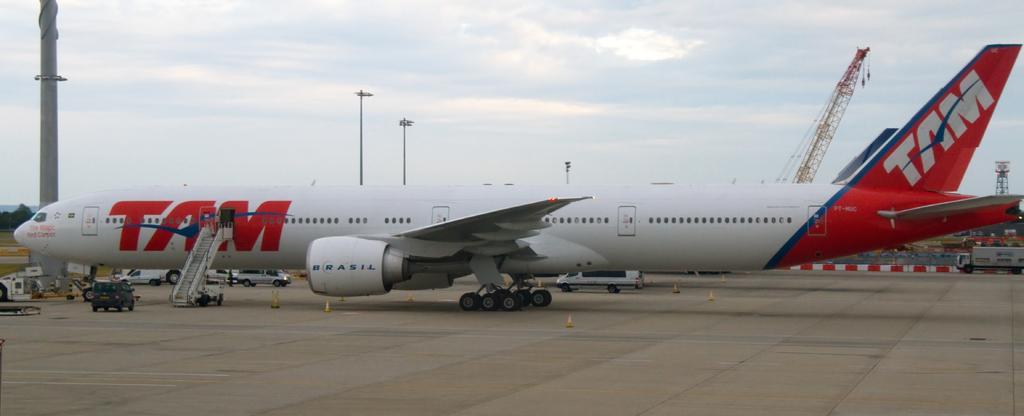Please provide a concise description of this image. In this image we can see an aeroplane present on the land. Image also consists of vehicles and also poles. In the background there is a cloudy sky. Trees are also visible in this image. 